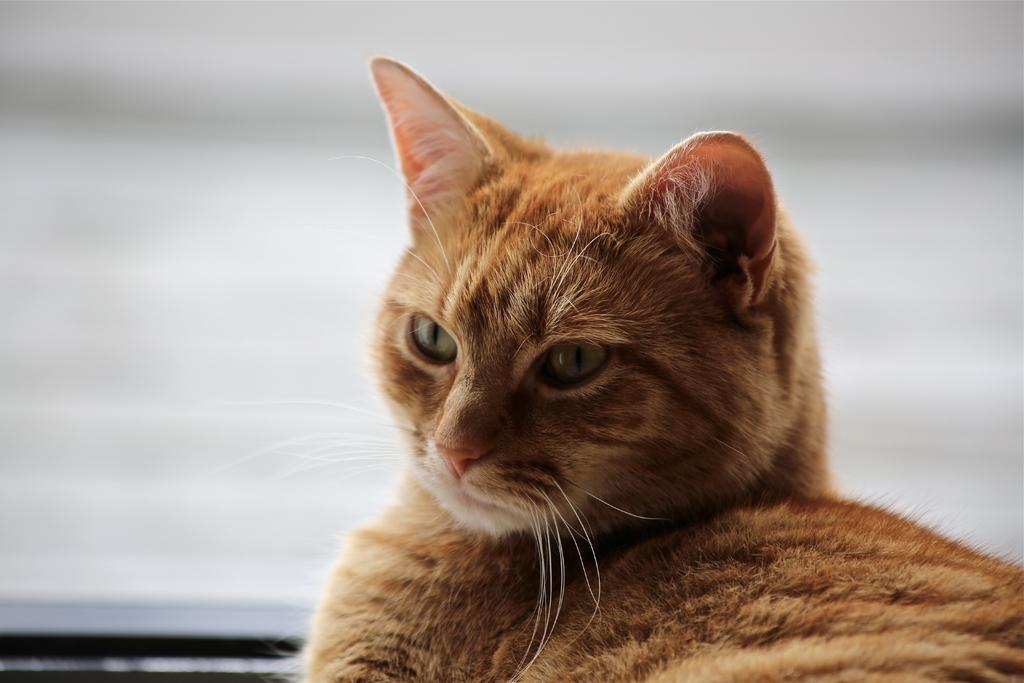What type of animal is present in the image? There is a cat in the image. What type of station does the cat represent in the image? The image does not depict a station, and the cat is not representing any type of station. 